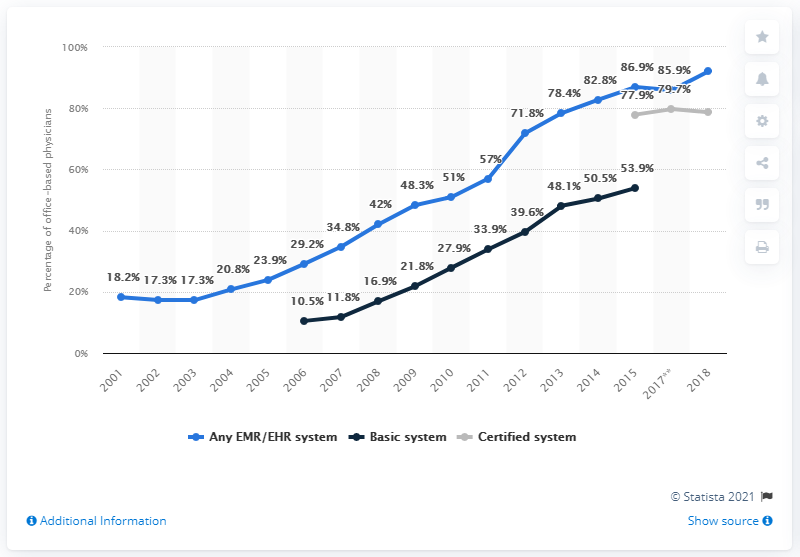Point out several critical features in this image. In 2012, the share of basic system was 8.5, while in 2013, it was different. In 2019, 92.1% of office-based U.S. physicians reported having any electronic medical record/electronic health record system. The blue line reached its lowest point in 2003. 